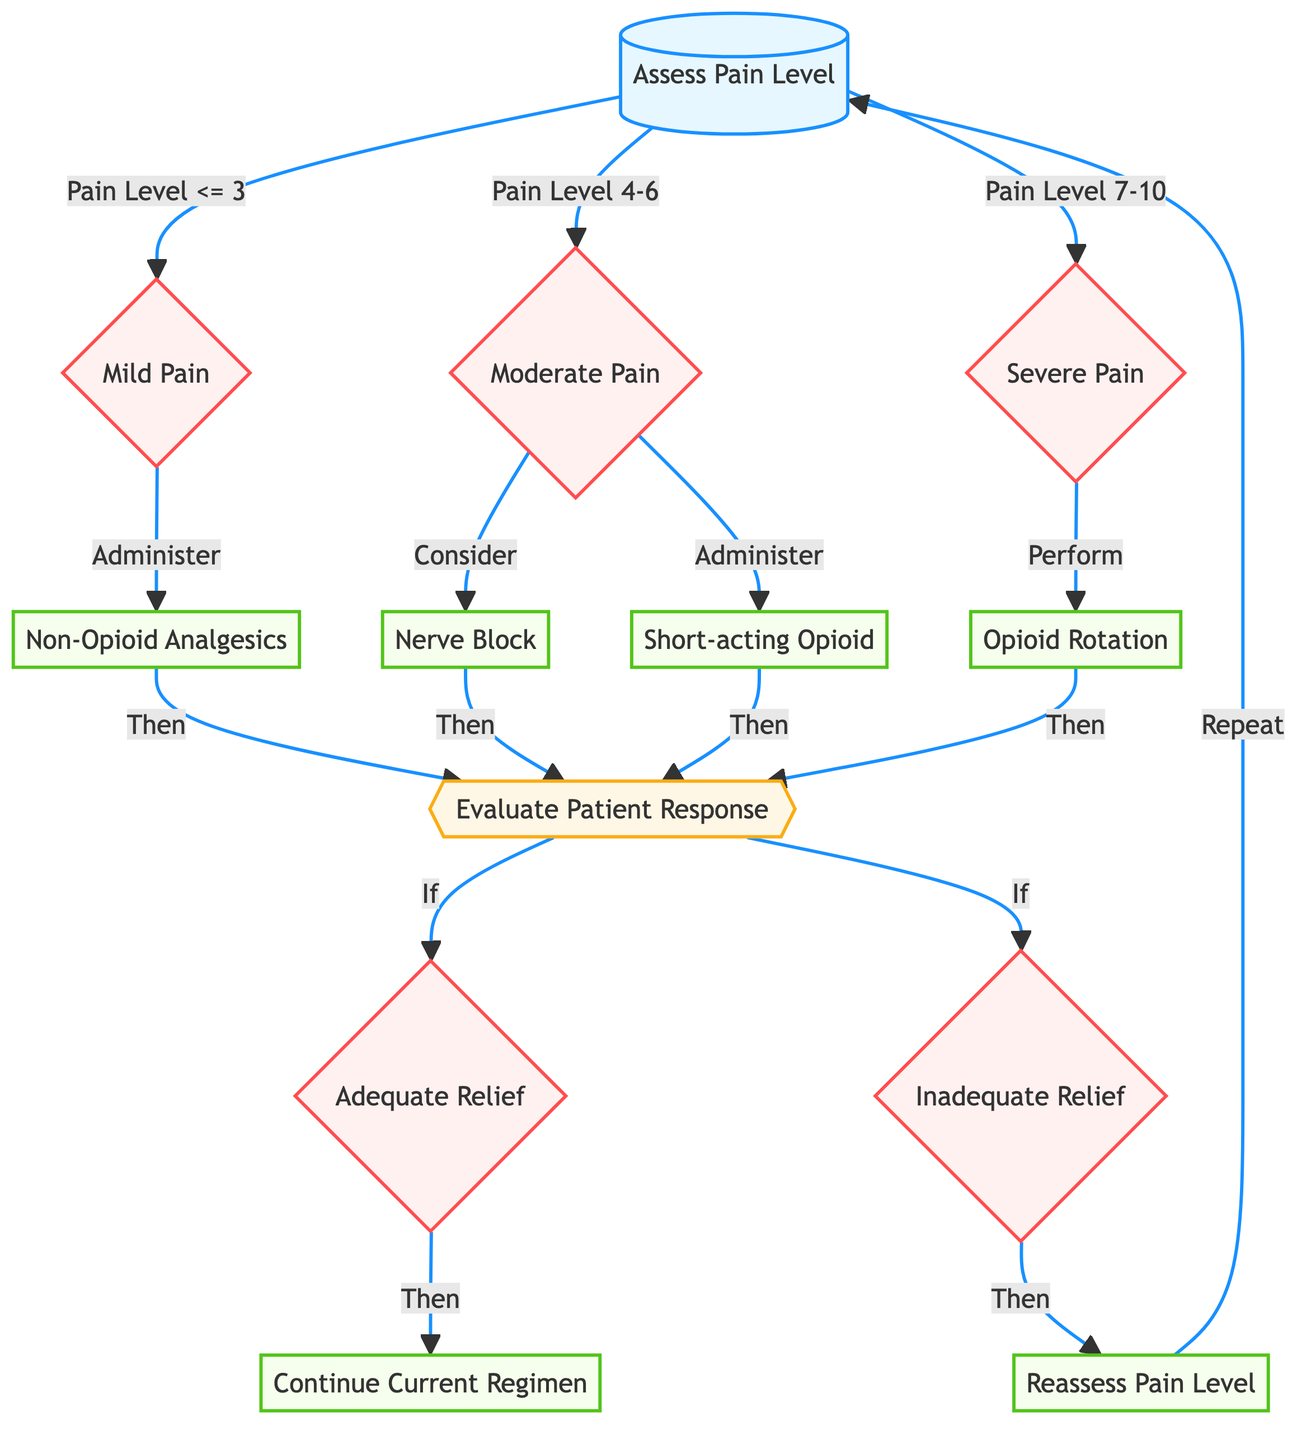What is the starting node of the decision tree? The starting node of the decision tree is labeled "Assess Pain Level". This is indicated as the first node in the flowchart, and it serves as the entry point for the decision-making process regarding postoperative pain management.
Answer: Assess Pain Level How many action nodes are there in the diagram? The action nodes in the diagram are "Non-Opioid Analgesics", "Nerve Block", "Short-acting Opioid", "Opioid Rotation", "Continue Current Regimen", and "Reassess Pain Level". By counting these nodes, we find there are six action nodes.
Answer: 6 What happens when the pain level is classified as "Moderate Pain"? When the pain level is classified as "Moderate Pain", the diagram shows two routes: "Consider Nerve Block" and "Administer Short-acting Opioid". This indicates that clinicians have the option to consider one action or perform another.
Answer: Consider Nerve Block, Administer Short-acting Opioid If a patient receives "Non-Opioid Analgesics", what is the next step? After administering "Non-Opioid Analgesics", the next step is to "Evaluate Patient Response". This indicates that the effectiveness of the analgesic needs to be assessed subsequently.
Answer: Evaluate Patient Response What decision is made after evaluating the patient’s response? After evaluating the patient's response, the decision is made whether the relief is "Adequate Relief" or "Inadequate Relief". This bifurcation defines the next steps the clinician takes based on the patient's pain relief outcome.
Answer: Adequate Relief, Inadequate Relief What should be done if the response is inadequate after treatment? If the response is inadequate after treatment, the next step is to "Reassess Pain Level". This signifies a review of the patient's situation, leading to further treatment decisions.
Answer: Reassess Pain Level How many nodes are there in total in the decision tree? To count the total number of nodes, we include all types: start, decision, action, and evaluation nodes. The diagram has 13 nodes in total, encompassing all the distinct steps in the decision process.
Answer: 13 Which action follows a decision of "Adequate Relief"? If the outcome is "Adequate Relief", the next action is to "Continue Current Regimen". This indicates that no alteration in the treatment approach is needed if pain management is deemed effective.
Answer: Continue Current Regimen What is the relationship between "Evaluate Patient Response" and "Reassess Pain Level"? The relationship is sequential; after evaluating the patient's response, if the relief is deemed inadequate, the clinician will take the action to "Reassess Pain Level". This connection highlights a continuous cycle of evaluation and adjustment in pain management.
Answer: Reassess Pain Level 